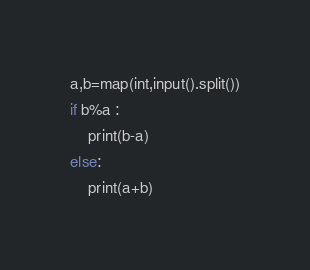Convert code to text. <code><loc_0><loc_0><loc_500><loc_500><_Python_>a,b=map(int,input().split())
if b%a :
    print(b-a)
else:
    print(a+b)</code> 